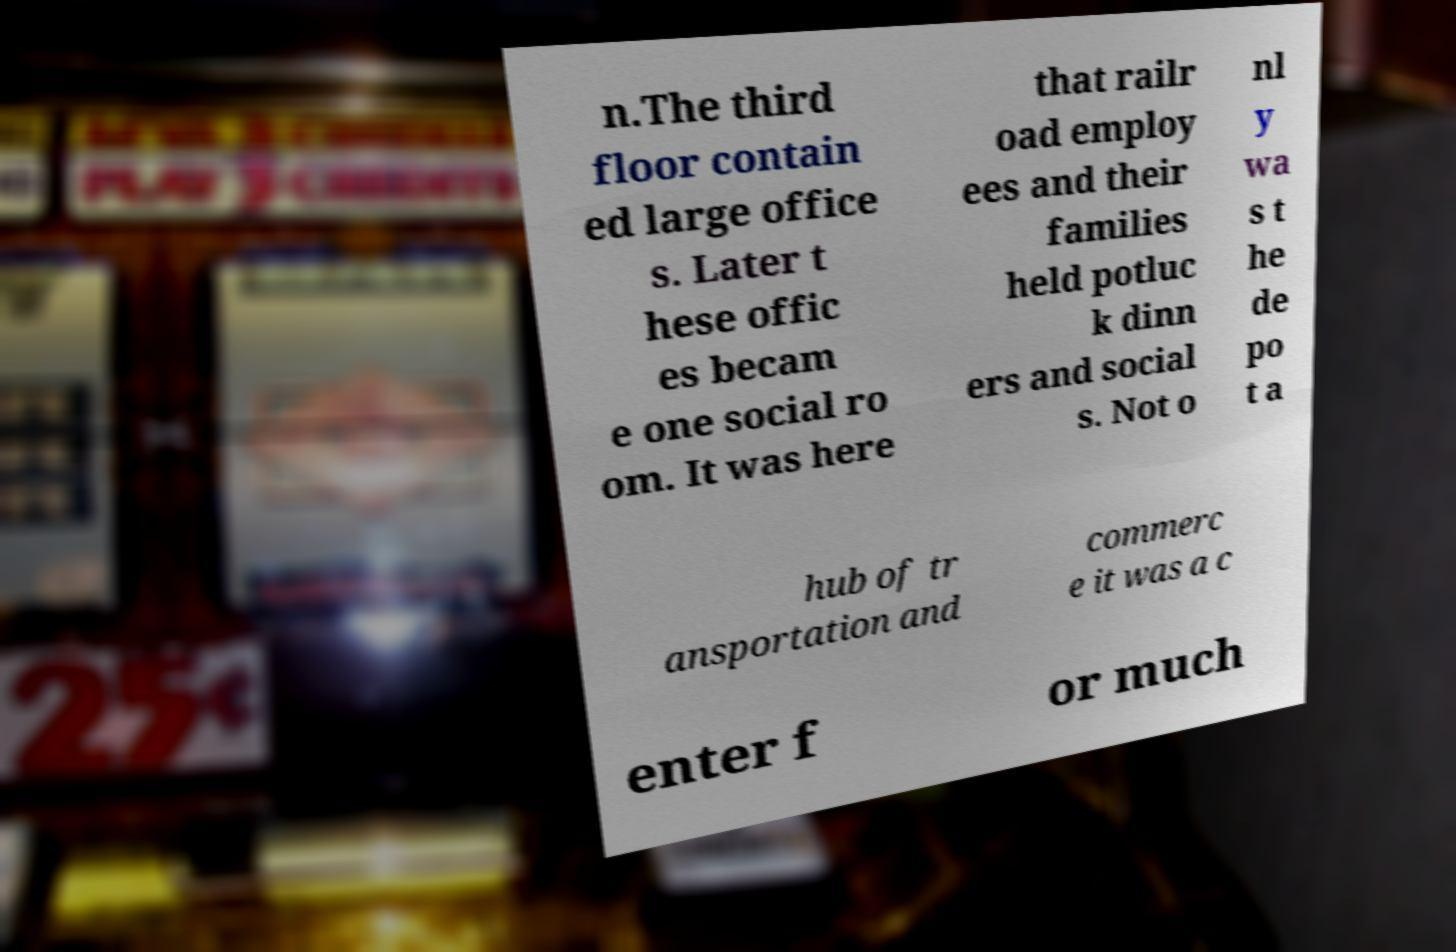I need the written content from this picture converted into text. Can you do that? n.The third floor contain ed large office s. Later t hese offic es becam e one social ro om. It was here that railr oad employ ees and their families held potluc k dinn ers and social s. Not o nl y wa s t he de po t a hub of tr ansportation and commerc e it was a c enter f or much 